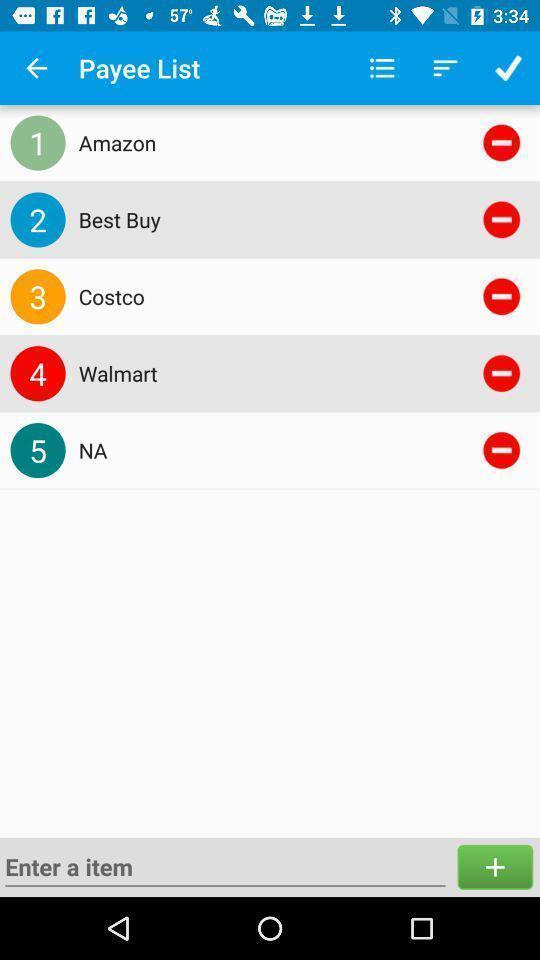Describe this image in words. Screen showing to select online stores. 